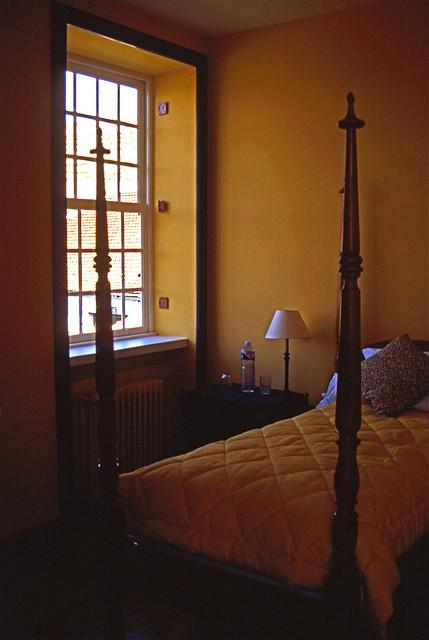What is the tip of the bed structures called? post 